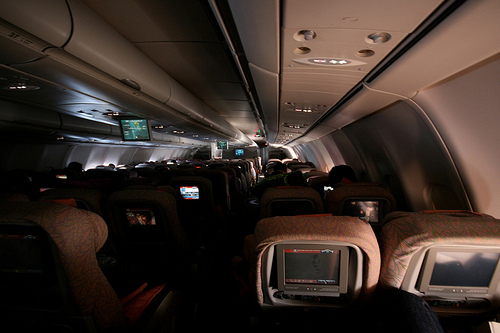<image>
Can you confirm if the tv is to the left of the seat? No. The tv is not to the left of the seat. From this viewpoint, they have a different horizontal relationship. 